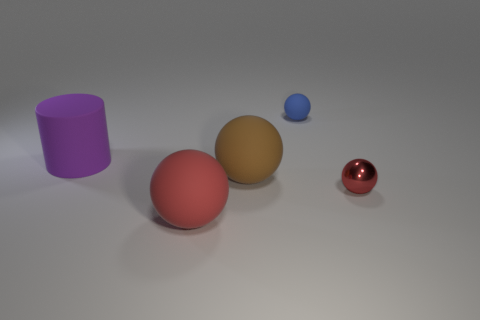Subtract 1 balls. How many balls are left? 3 Add 4 large red rubber things. How many objects exist? 9 Subtract all balls. How many objects are left? 1 Subtract all small cyan cylinders. Subtract all balls. How many objects are left? 1 Add 3 matte spheres. How many matte spheres are left? 6 Add 2 big purple matte objects. How many big purple matte objects exist? 3 Subtract 1 purple cylinders. How many objects are left? 4 